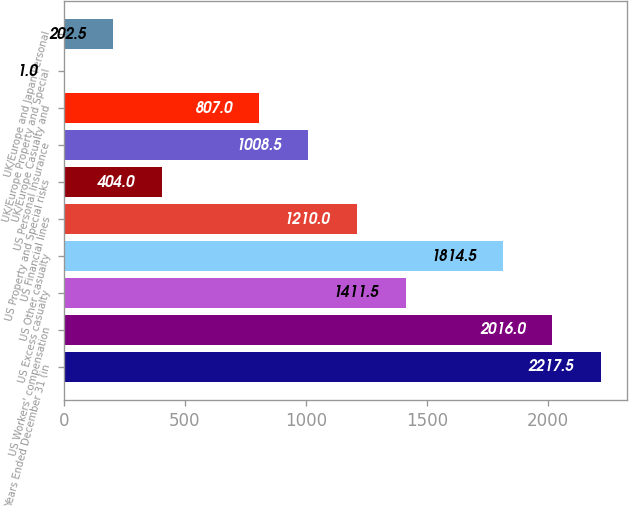Convert chart. <chart><loc_0><loc_0><loc_500><loc_500><bar_chart><fcel>Years Ended December 31 (in<fcel>US Workers' compensation<fcel>US Excess casualty<fcel>US Other casualty<fcel>US Financial lines<fcel>US Property and Special risks<fcel>US Personal Insurance<fcel>UK/Europe Casualty and<fcel>UK/Europe Property and Special<fcel>UK/Europe and Japan Personal<nl><fcel>2217.5<fcel>2016<fcel>1411.5<fcel>1814.5<fcel>1210<fcel>404<fcel>1008.5<fcel>807<fcel>1<fcel>202.5<nl></chart> 